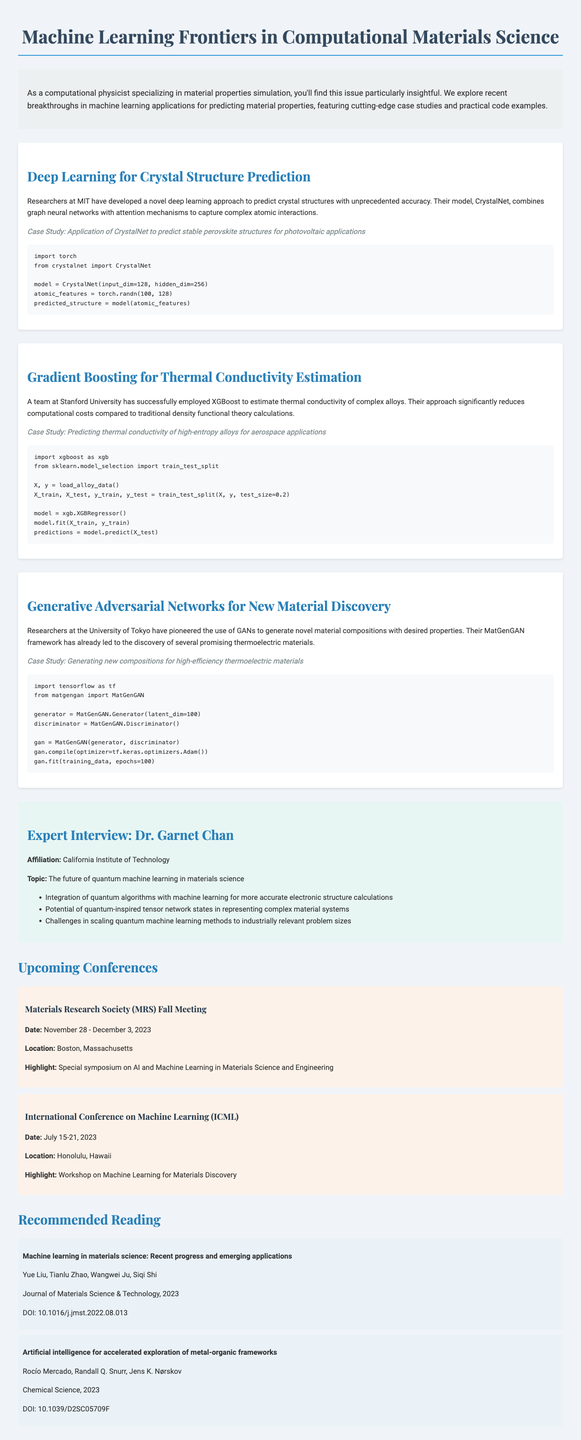What is the title of the newsletter? The title of the newsletter is found at the beginning of the document.
Answer: Machine Learning Frontiers in Computational Materials Science Who developed the CrystalNet model? This information is mentioned in the section about deep learning for crystal structure prediction.
Answer: MIT What machine learning technique was used to estimate thermal conductivity? The section on thermal conductivity estimation provides this detail.
Answer: XGBoost What is the main application focus of the case study involving CrystalNet? The case study for CrystalNet indicates its specific application area.
Answer: Photovoltaic applications What is the date of the upcoming Materials Research Society Fall Meeting? The date is listed under the upcoming conferences section.
Answer: November 28 - December 3, 2023 Who is the expert interviewed in this newsletter? This detail is highlighted in the expert interview section.
Answer: Dr. Garnet Chan What framework was used for generating new materials? The content section on generative adversarial networks mentions this framework.
Answer: MatGenGAN What are the key points discussed by Dr. Garnet Chan? This question pertains to the listed bullet points under the expert interview.
Answer: Integration of quantum algorithms with machine learning for more accurate electronic structure calculations 